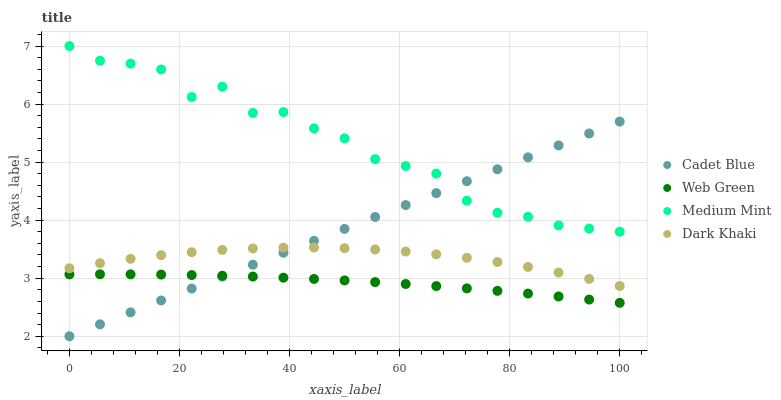Does Web Green have the minimum area under the curve?
Answer yes or no. Yes. Does Medium Mint have the maximum area under the curve?
Answer yes or no. Yes. Does Dark Khaki have the minimum area under the curve?
Answer yes or no. No. Does Dark Khaki have the maximum area under the curve?
Answer yes or no. No. Is Cadet Blue the smoothest?
Answer yes or no. Yes. Is Medium Mint the roughest?
Answer yes or no. Yes. Is Dark Khaki the smoothest?
Answer yes or no. No. Is Dark Khaki the roughest?
Answer yes or no. No. Does Cadet Blue have the lowest value?
Answer yes or no. Yes. Does Dark Khaki have the lowest value?
Answer yes or no. No. Does Medium Mint have the highest value?
Answer yes or no. Yes. Does Dark Khaki have the highest value?
Answer yes or no. No. Is Dark Khaki less than Medium Mint?
Answer yes or no. Yes. Is Medium Mint greater than Web Green?
Answer yes or no. Yes. Does Medium Mint intersect Cadet Blue?
Answer yes or no. Yes. Is Medium Mint less than Cadet Blue?
Answer yes or no. No. Is Medium Mint greater than Cadet Blue?
Answer yes or no. No. Does Dark Khaki intersect Medium Mint?
Answer yes or no. No. 